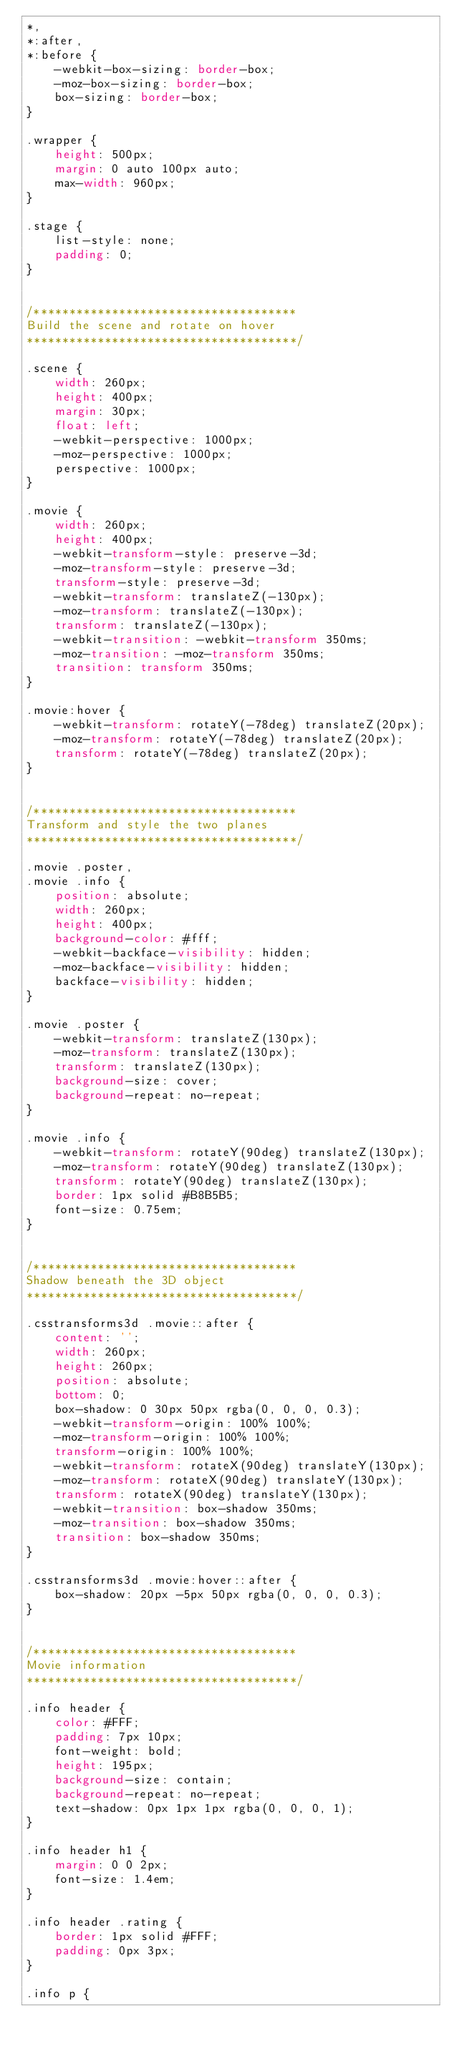<code> <loc_0><loc_0><loc_500><loc_500><_CSS_>*,
*:after,
*:before {
    -webkit-box-sizing: border-box;
    -moz-box-sizing: border-box;
    box-sizing: border-box;
}

.wrapper {
    height: 500px;
    margin: 0 auto 100px auto;
    max-width: 960px;
}

.stage {
    list-style: none;
    padding: 0;
}


/*************************************
Build the scene and rotate on hover
**************************************/

.scene {
    width: 260px;
    height: 400px;
    margin: 30px;
    float: left;
    -webkit-perspective: 1000px;
    -moz-perspective: 1000px;
    perspective: 1000px;
}

.movie {
    width: 260px;
    height: 400px;
    -webkit-transform-style: preserve-3d;
    -moz-transform-style: preserve-3d;
    transform-style: preserve-3d;
    -webkit-transform: translateZ(-130px);
    -moz-transform: translateZ(-130px);
    transform: translateZ(-130px);
    -webkit-transition: -webkit-transform 350ms;
    -moz-transition: -moz-transform 350ms;
    transition: transform 350ms;
}

.movie:hover {
    -webkit-transform: rotateY(-78deg) translateZ(20px);
    -moz-transform: rotateY(-78deg) translateZ(20px);
    transform: rotateY(-78deg) translateZ(20px);
}


/*************************************
Transform and style the two planes
**************************************/

.movie .poster,
.movie .info {
    position: absolute;
    width: 260px;
    height: 400px;
    background-color: #fff;
    -webkit-backface-visibility: hidden;
    -moz-backface-visibility: hidden;
    backface-visibility: hidden;
}

.movie .poster {
    -webkit-transform: translateZ(130px);
    -moz-transform: translateZ(130px);
    transform: translateZ(130px);
    background-size: cover;
    background-repeat: no-repeat;
}

.movie .info {
    -webkit-transform: rotateY(90deg) translateZ(130px);
    -moz-transform: rotateY(90deg) translateZ(130px);
    transform: rotateY(90deg) translateZ(130px);
    border: 1px solid #B8B5B5;
    font-size: 0.75em;
}


/*************************************
Shadow beneath the 3D object
**************************************/

.csstransforms3d .movie::after {
    content: '';
    width: 260px;
    height: 260px;
    position: absolute;
    bottom: 0;
    box-shadow: 0 30px 50px rgba(0, 0, 0, 0.3);
    -webkit-transform-origin: 100% 100%;
    -moz-transform-origin: 100% 100%;
    transform-origin: 100% 100%;
    -webkit-transform: rotateX(90deg) translateY(130px);
    -moz-transform: rotateX(90deg) translateY(130px);
    transform: rotateX(90deg) translateY(130px);
    -webkit-transition: box-shadow 350ms;
    -moz-transition: box-shadow 350ms;
    transition: box-shadow 350ms;
}

.csstransforms3d .movie:hover::after {
    box-shadow: 20px -5px 50px rgba(0, 0, 0, 0.3);
}


/*************************************
Movie information
**************************************/

.info header {
    color: #FFF;
    padding: 7px 10px;
    font-weight: bold;
    height: 195px;
    background-size: contain;
    background-repeat: no-repeat;
    text-shadow: 0px 1px 1px rgba(0, 0, 0, 1);
}

.info header h1 {
    margin: 0 0 2px;
    font-size: 1.4em;
}

.info header .rating {
    border: 1px solid #FFF;
    padding: 0px 3px;
}

.info p {</code> 